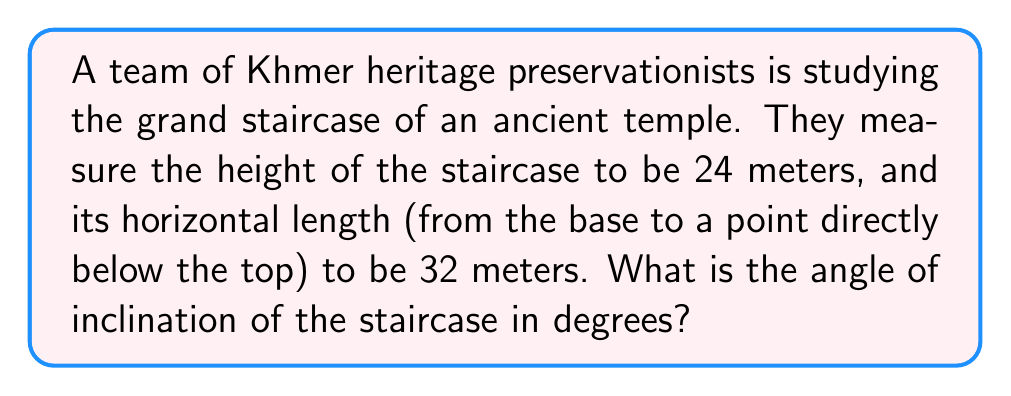Solve this math problem. To solve this problem, we'll use trigonometry. Let's approach this step-by-step:

1) First, let's visualize the problem. The staircase forms a right triangle with the ground, where:
   - The height of the staircase is the opposite side (24 meters)
   - The horizontal length is the adjacent side (32 meters)
   - The angle of inclination is the angle we're looking for

2) In a right triangle, the tangent of an angle is the ratio of the opposite side to the adjacent side. So:

   $$\tan(\theta) = \frac{\text{opposite}}{\text{adjacent}} = \frac{24}{32}$$

3) Simplify this fraction:

   $$\tan(\theta) = \frac{3}{4}$$

4) To find the angle, we need to use the inverse tangent (arctan or $\tan^{-1}$) function:

   $$\theta = \tan^{-1}\left(\frac{3}{4}\right)$$

5) Using a calculator or computer, we can evaluate this:

   $$\theta \approx 36.87\text{°}$$

6) Rounding to the nearest degree:

   $$\theta \approx 37\text{°}$$

Thus, the angle of inclination of the ancient Khmer temple stairs is approximately 37 degrees.
Answer: $37\text{°}$ 